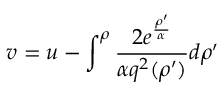Convert formula to latex. <formula><loc_0><loc_0><loc_500><loc_500>v = u - \int ^ { \rho } { \frac { 2 e ^ { \frac { \rho ^ { \prime } } { \alpha } } } { \alpha q ^ { 2 } ( \rho ^ { \prime } ) } } d \rho ^ { \prime }</formula> 